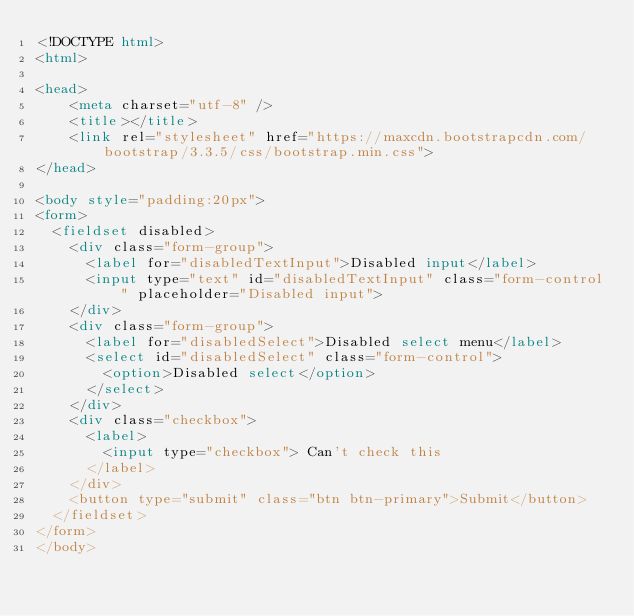<code> <loc_0><loc_0><loc_500><loc_500><_HTML_><!DOCTYPE html>
<html>

<head>
    <meta charset="utf-8" />
    <title></title>
    <link rel="stylesheet" href="https://maxcdn.bootstrapcdn.com/bootstrap/3.3.5/css/bootstrap.min.css">
</head>

<body style="padding:20px">
<form>
  <fieldset disabled>
    <div class="form-group">
      <label for="disabledTextInput">Disabled input</label>
      <input type="text" id="disabledTextInput" class="form-control" placeholder="Disabled input">
    </div>
    <div class="form-group">
      <label for="disabledSelect">Disabled select menu</label>
      <select id="disabledSelect" class="form-control">
        <option>Disabled select</option>
      </select>
    </div>
    <div class="checkbox">
      <label>
        <input type="checkbox"> Can't check this
      </label>
    </div>
    <button type="submit" class="btn btn-primary">Submit</button>
  </fieldset>
</form>
</body></code> 